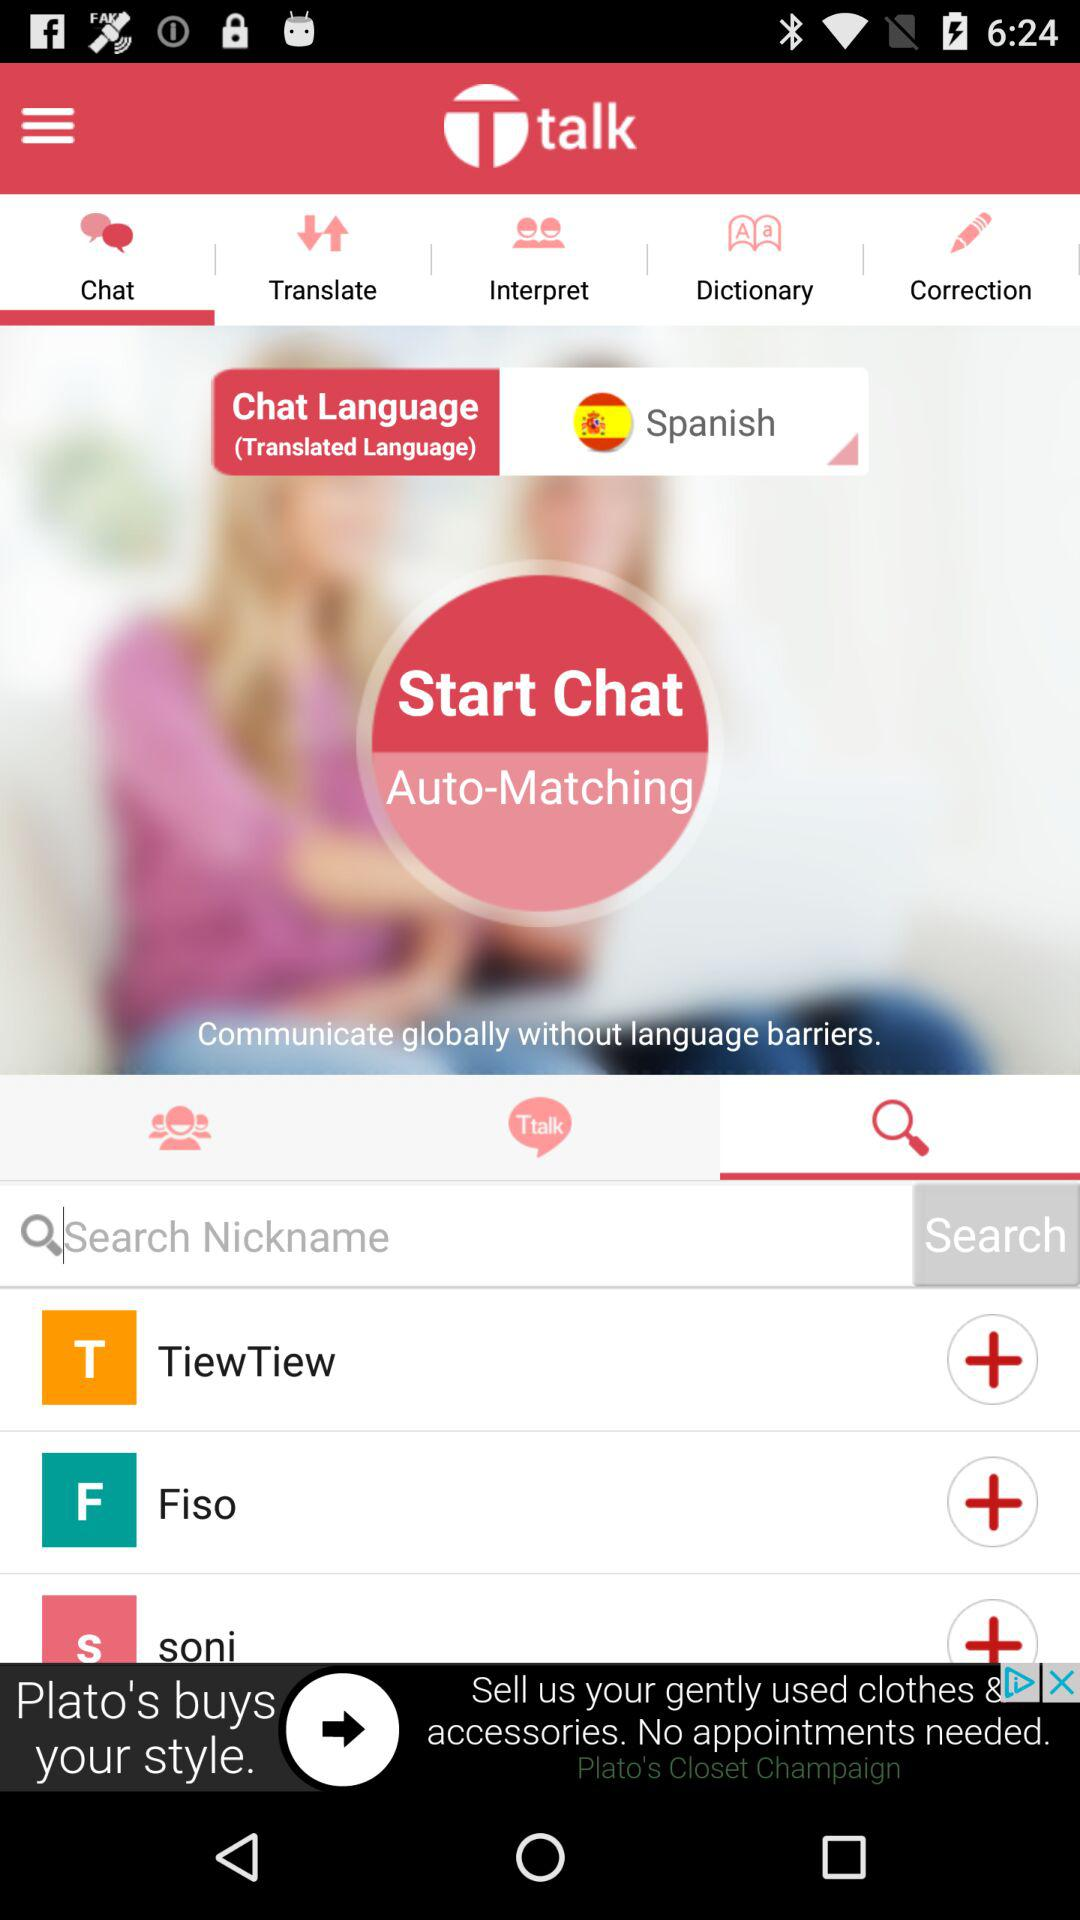What is the chat language? The chat language is Spanish. 